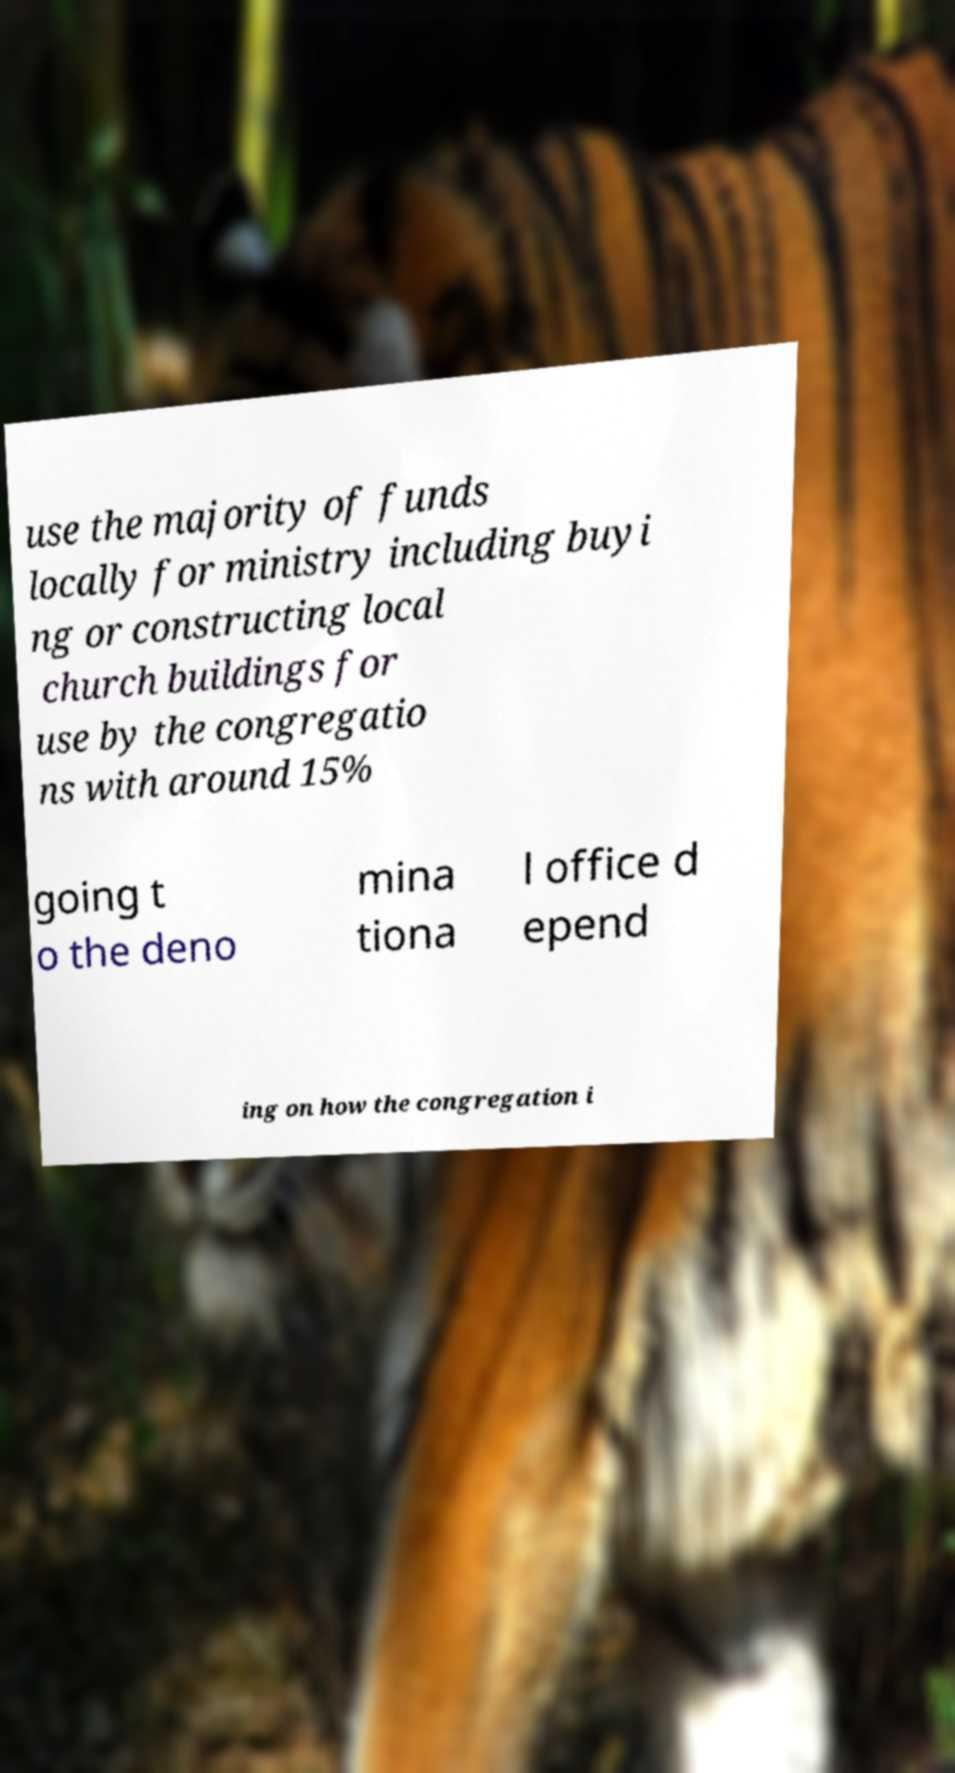Can you read and provide the text displayed in the image?This photo seems to have some interesting text. Can you extract and type it out for me? use the majority of funds locally for ministry including buyi ng or constructing local church buildings for use by the congregatio ns with around 15% going t o the deno mina tiona l office d epend ing on how the congregation i 